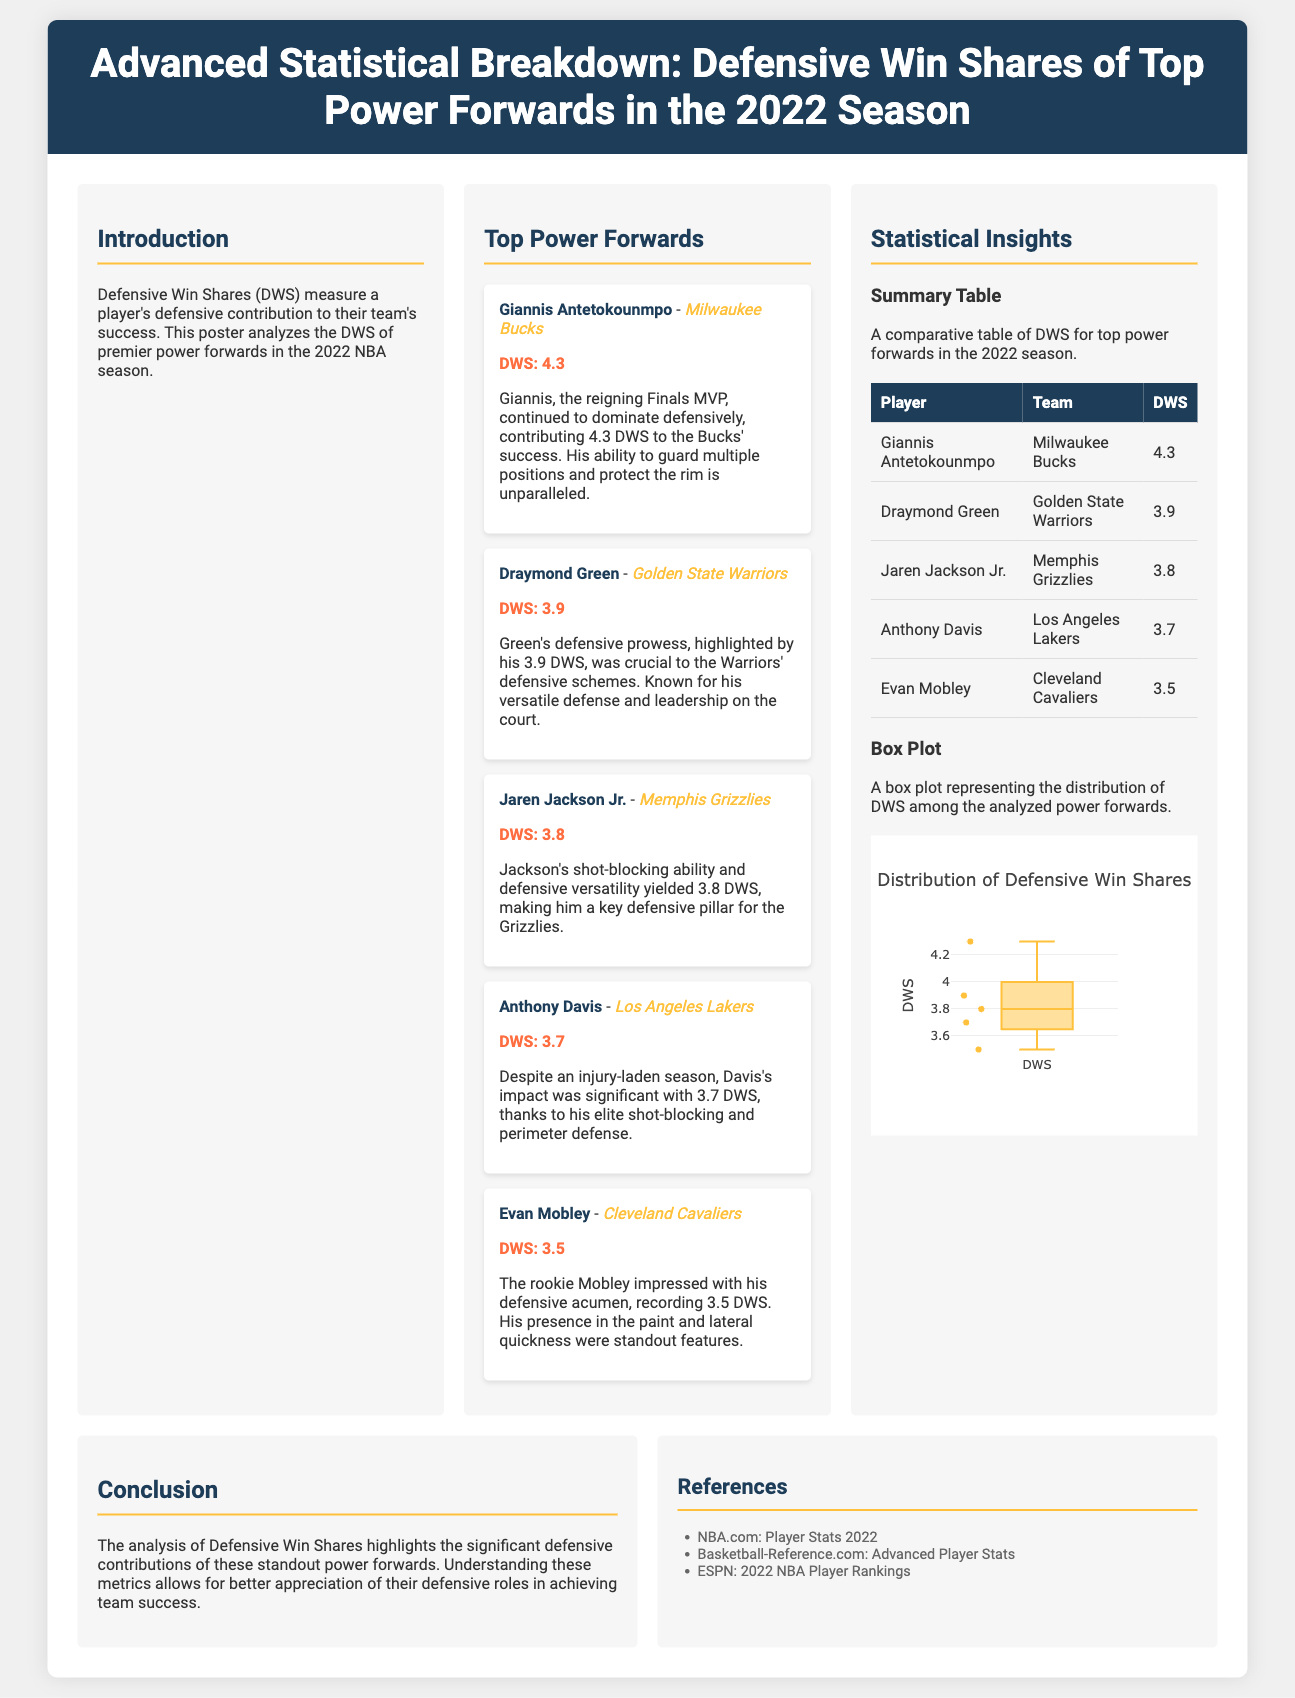What measure does DWS represent? DWS stands for Defensive Win Shares, which measure a player's defensive contribution to their team's success.
Answer: Defensive contribution Who had the highest DWS in the 2022 season among power forwards? The player with the highest DWS listed in the document is Giannis Antetokounmpo, who had 4.3 DWS.
Answer: Giannis Antetokounmpo How many DWS did Draymond Green achieve in the 2022 season? The document specifies that Draymond Green had a DWS of 3.9.
Answer: 3.9 What team did Jaren Jackson Jr. play for? According to the poster, Jaren Jackson Jr. played for the Memphis Grizzlies.
Answer: Memphis Grizzlies What is the minimum DWS recorded by the top power forwards in the 2022 season? The minimum DWS listed for the top power forwards is 3.5, achieved by Evan Mobley.
Answer: 3.5 Which power forward is noted for being a rookie with significant defensive acumen? The document mentions Evan Mobley as the rookie who impressed with his defensive skills.
Answer: Evan Mobley What statistical feature is displayed in the box plot? The box plot represents the distribution of Defensive Win Shares (DWS) among the analyzed players.
Answer: Distribution of DWS Which player is recognized for shot-blocking ability in the document? Jaren Jackson Jr. is highlighted for his shot-blocking ability.
Answer: Jaren Jackson Jr Which reference source is mentioned first in the document? The first reference source listed is NBA.com: Player Stats 2022.
Answer: NBA.com: Player Stats 2022 